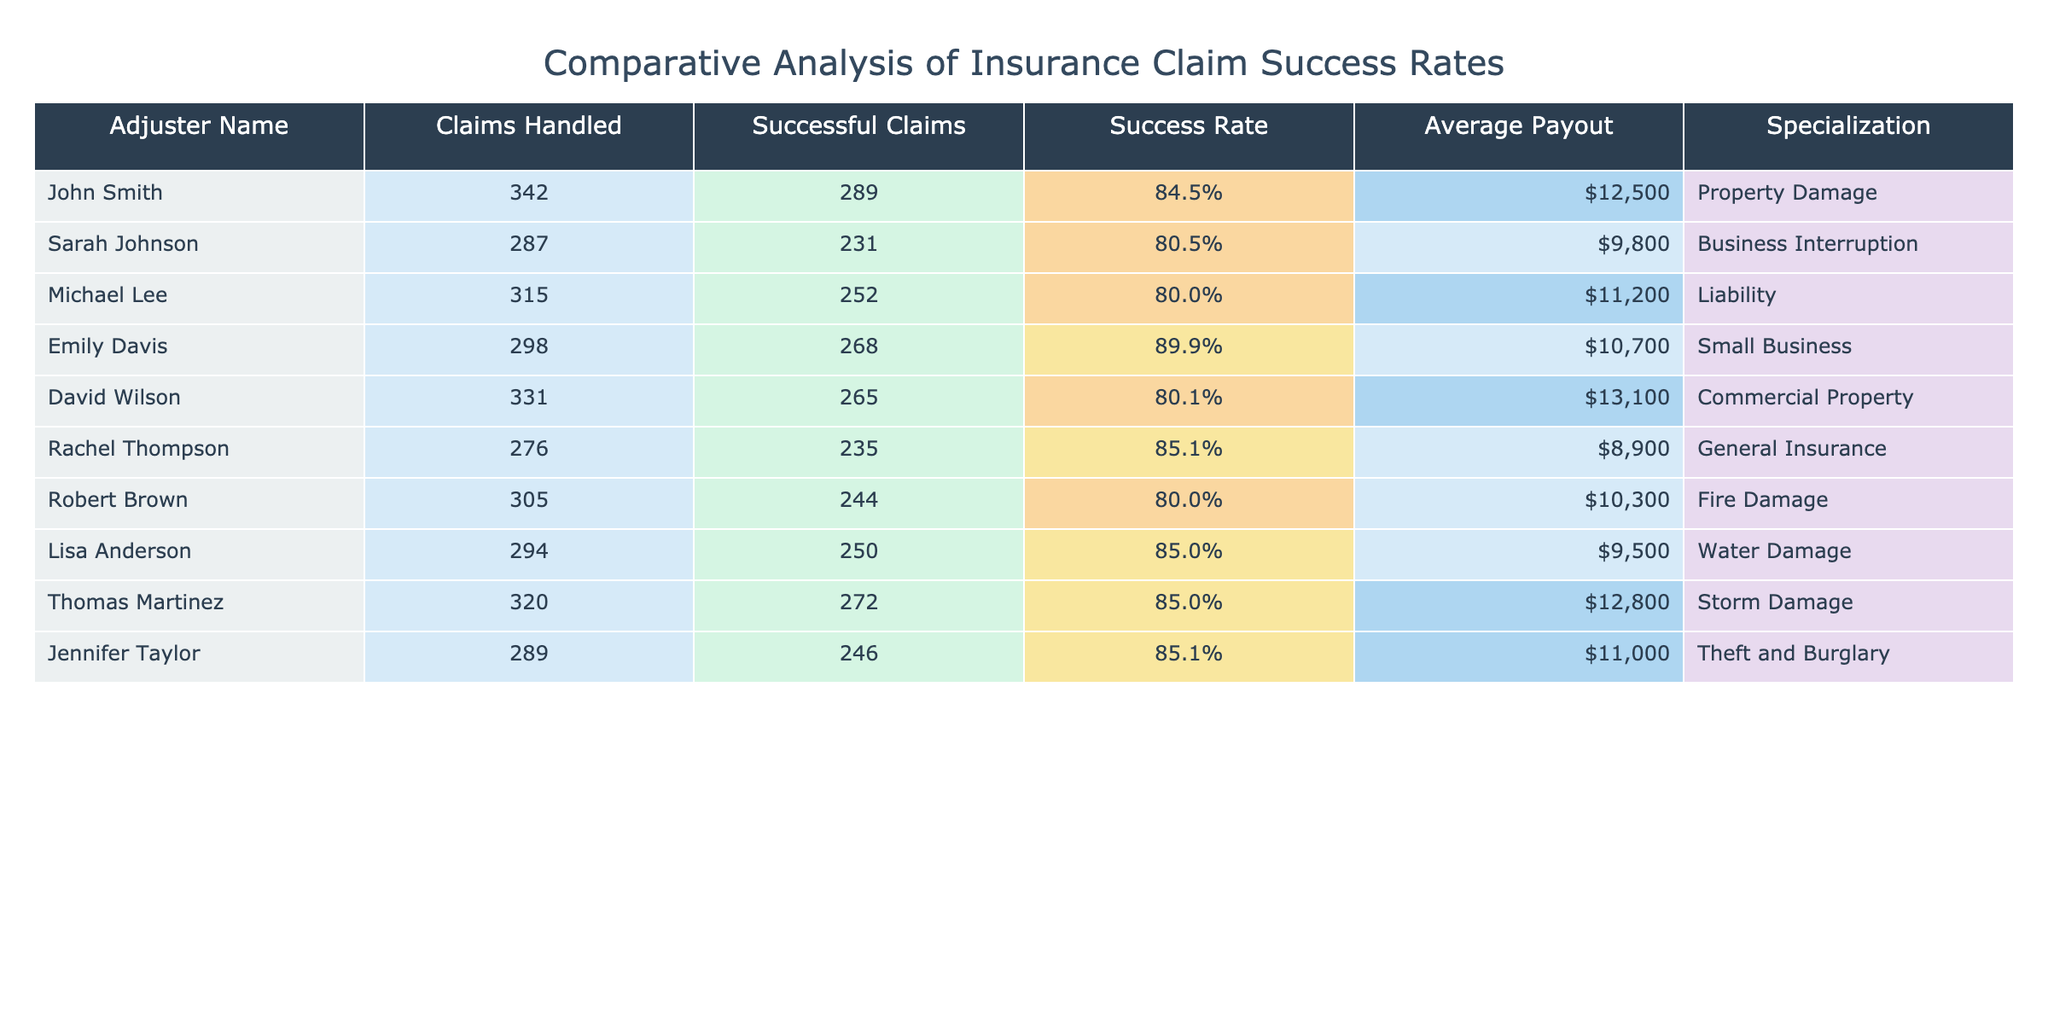What is the success rate of Emily Davis? The table shows that Emily Davis has a success rate listed as 89.9%.
Answer: 89.9% Which adjuster has the highest success rate? The highest success rate in the table is for Emily Davis at 89.9%.
Answer: Emily Davis How many claims did Sarah Johnson handle? According to the table, Sarah Johnson handled 287 claims.
Answer: 287 What is the average payout for Thomas Martinez? The average payout for Thomas Martinez is listed as $12,800 in the table.
Answer: $12,800 Is there an adjuster with a success rate of 85% or higher? Yes, there are multiple adjusters with a success rate of 85% or higher: Emily Davis, Thomas Martinez, Jennifer Taylor, Rachel Thompson, and Lisa Anderson.
Answer: Yes What is the average number of claims handled across all adjusters? Adding the claims handled by all adjusters gives a total of 3,078 claims (342 + 287 + 315 + 298 + 331 + 276 + 305 + 294 + 320 + 289). There are 10 adjusters, so the average is 3,078 / 10 = 307.8.
Answer: 307.8 Which adjuster has the lowest average payout? By comparing the average payouts, Rachel Thompson has the lowest average payout at $8,900.
Answer: Rachel Thompson What is the difference in success rates between John Smith and Michael Lee? John Smith has a success rate of 84.5% and Michael Lee has 80.0%. The difference is 84.5% - 80.0% = 4.5%.
Answer: 4.5% How many successful claims did Robert Brown handle? The table states that Robert Brown had 244 successful claims.
Answer: 244 What is the overall success rate of all adjusters combined? The total successful claims sum to 2,601 (289 + 231 + 252 + 268 + 265 + 235 + 244 + 250 + 272 + 246) and total claims handled is 3,078. Therefore, the overall success rate is 2,601 / 3,078 = 84.6%.
Answer: 84.6% 